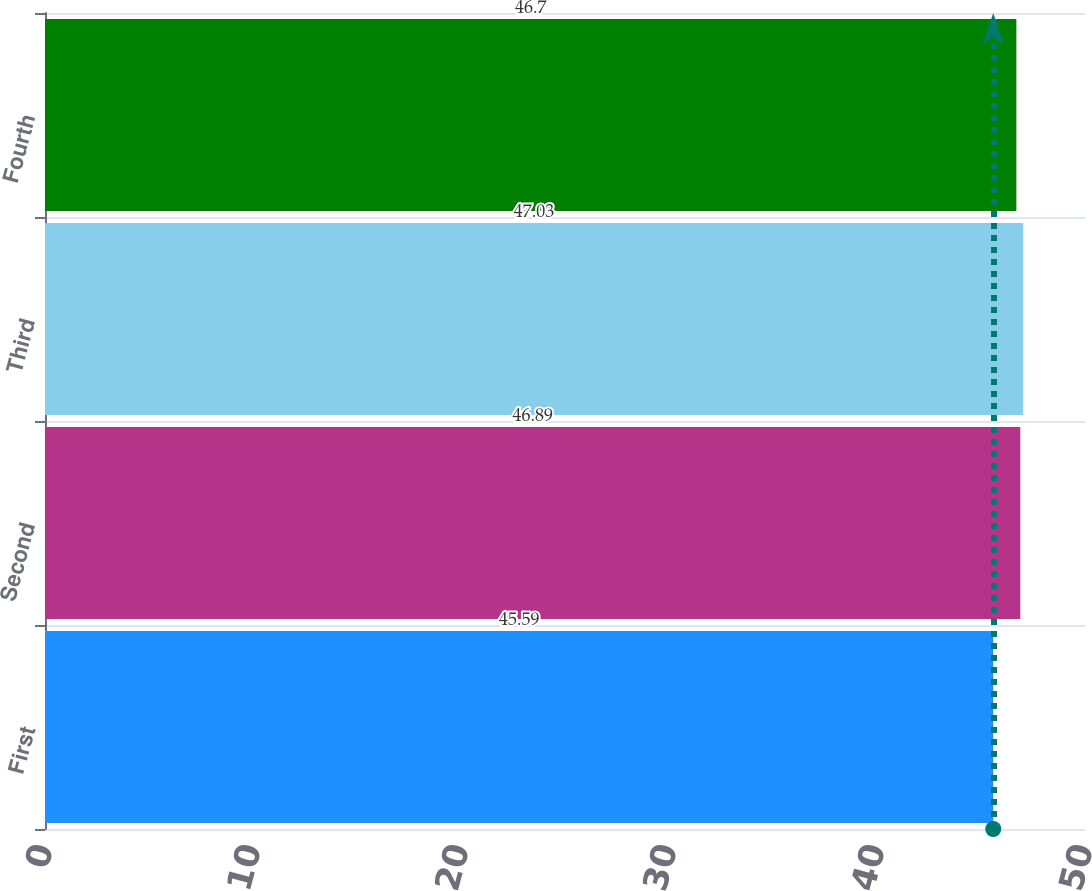Convert chart. <chart><loc_0><loc_0><loc_500><loc_500><bar_chart><fcel>First<fcel>Second<fcel>Third<fcel>Fourth<nl><fcel>45.59<fcel>46.89<fcel>47.03<fcel>46.7<nl></chart> 